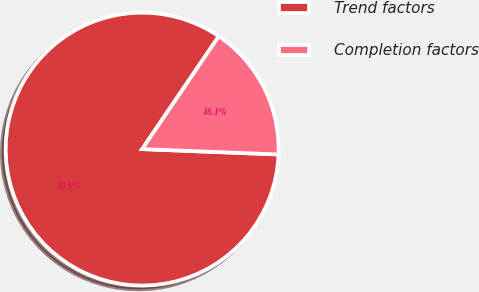Convert chart to OTSL. <chart><loc_0><loc_0><loc_500><loc_500><pie_chart><fcel>Trend factors<fcel>Completion factors<nl><fcel>83.87%<fcel>16.13%<nl></chart> 